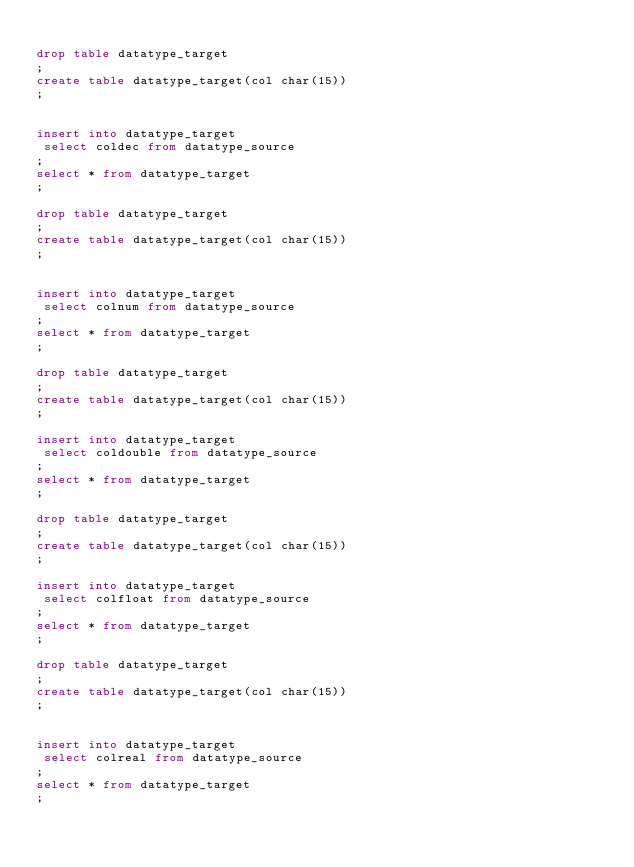Convert code to text. <code><loc_0><loc_0><loc_500><loc_500><_SQL_>
drop table datatype_target
;
create table datatype_target(col char(15))
;


insert into datatype_target
 select coldec from datatype_source
;
select * from datatype_target
;

drop table datatype_target
;
create table datatype_target(col char(15))
;


insert into datatype_target
 select colnum from datatype_source
;
select * from datatype_target
;

drop table datatype_target
;
create table datatype_target(col char(15))
;

insert into datatype_target
 select coldouble from datatype_source
;
select * from datatype_target
;

drop table datatype_target
;
create table datatype_target(col char(15))
;

insert into datatype_target
 select colfloat from datatype_source
;
select * from datatype_target
;

drop table datatype_target
;
create table datatype_target(col char(15))
;


insert into datatype_target
 select colreal from datatype_source
;
select * from datatype_target
;
</code> 